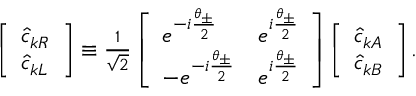<formula> <loc_0><loc_0><loc_500><loc_500>\begin{array} { r } { \left [ \begin{array} { l } { \hat { c } _ { k R } } \\ { \hat { c } _ { k L } } \end{array} \right ] \equiv \frac { 1 } { \sqrt { 2 } } \left [ \begin{array} { l l } { e ^ { - i \frac { \theta _ { \pm } } { 2 } } } & { e ^ { i \frac { \theta _ { \pm } } { 2 } } } \\ { - e ^ { - i \frac { \theta _ { \pm } } { 2 } } } & { e ^ { i \frac { \theta _ { \pm } } { 2 } } } \end{array} \right ] \left [ \begin{array} { l } { \hat { c } _ { k A } } \\ { \hat { c } _ { k B } } \end{array} \right ] . } \end{array}</formula> 